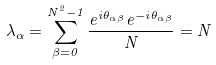Convert formula to latex. <formula><loc_0><loc_0><loc_500><loc_500>\lambda _ { \alpha } = \sum _ { \beta = 0 } ^ { N ^ { 2 } - 1 } \frac { e ^ { i \theta _ { \alpha \beta } } e ^ { - i \theta _ { \alpha \beta } } } { N } = N</formula> 